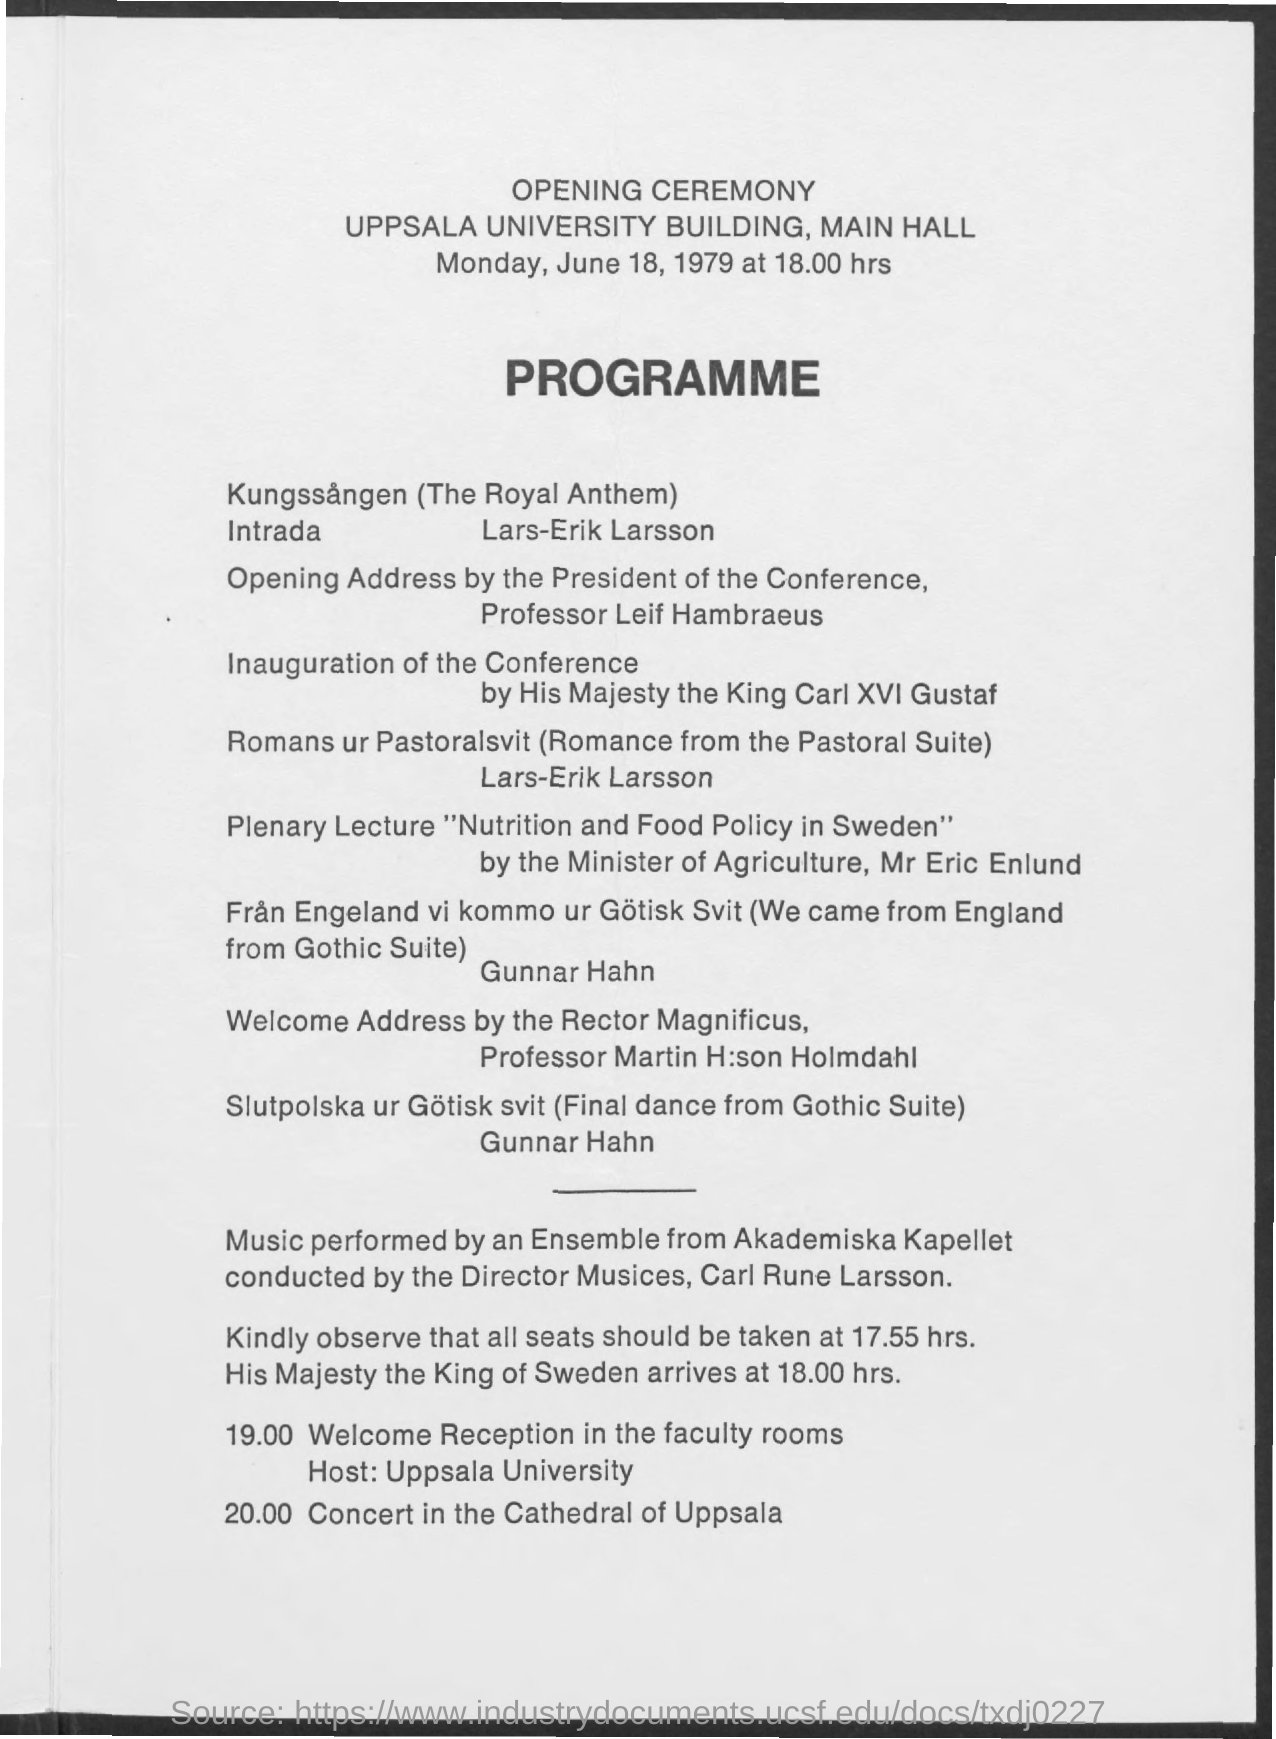Outline some significant characteristics in this image. The ceremony is scheduled to be held on June 18, 1979. The ceremony will start at 18:00 hours. Professor Leif Hambraeus is the President of the Conference. The ceremony will be held at Uppsala University Building, in the Main Hall. At 8:00 PM, there is a scheduled concert in the Cathedral of Uppsala. 